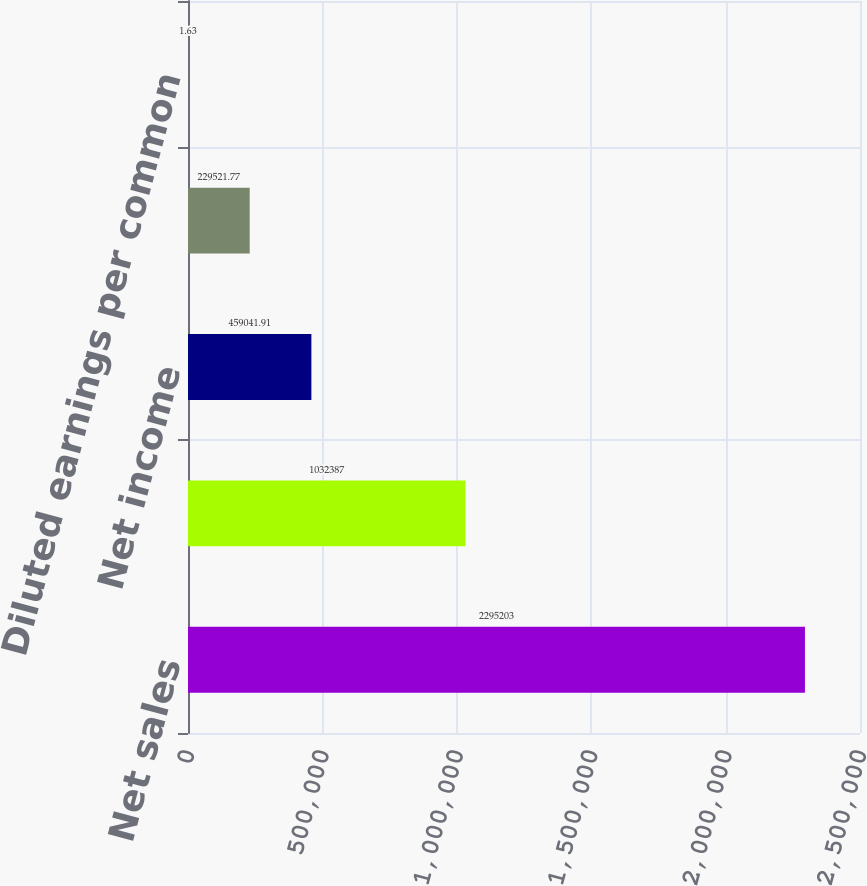Convert chart. <chart><loc_0><loc_0><loc_500><loc_500><bar_chart><fcel>Net sales<fcel>Gross profit<fcel>Net income<fcel>Basic earnings per common<fcel>Diluted earnings per common<nl><fcel>2.2952e+06<fcel>1.03239e+06<fcel>459042<fcel>229522<fcel>1.63<nl></chart> 